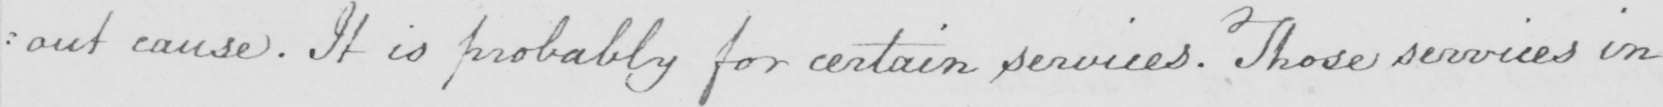What is written in this line of handwriting? : out cause . It is probably for certain services . Those services in 